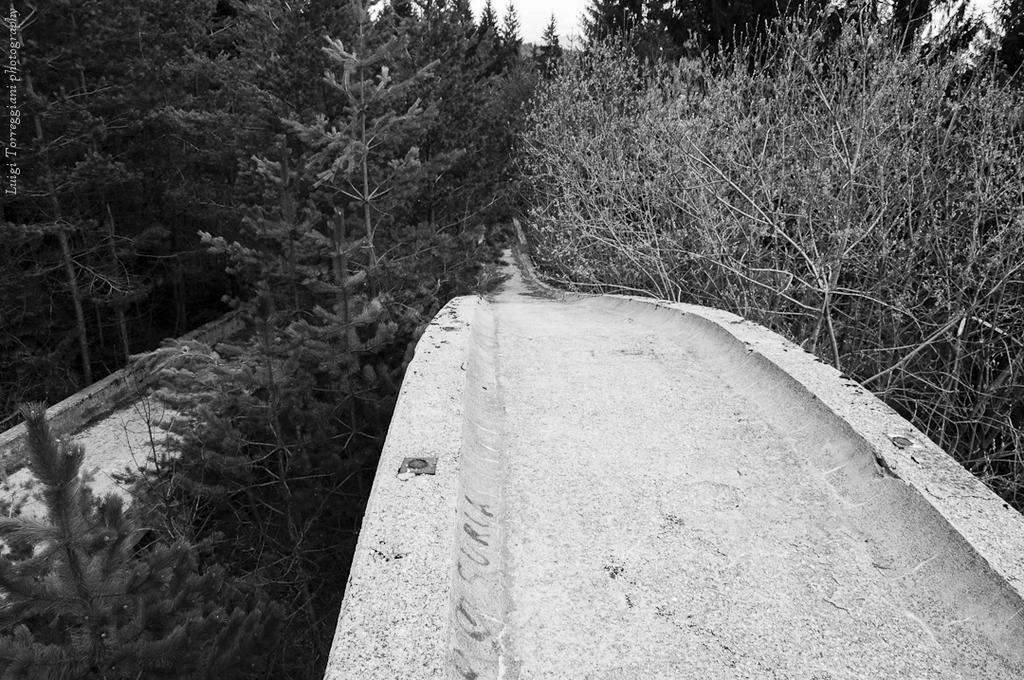Could you give a brief overview of what you see in this image? In this black and white image there is a path in the foreground. There are trees and sky in the background and text on the left side. 